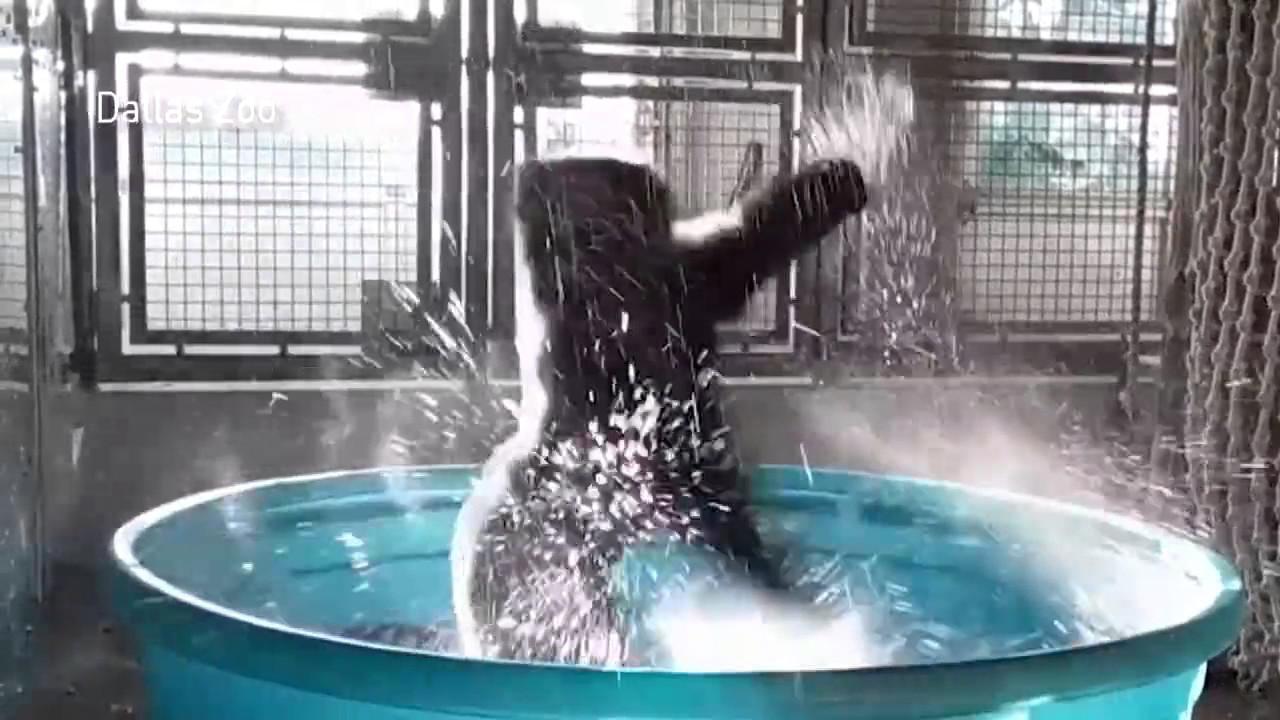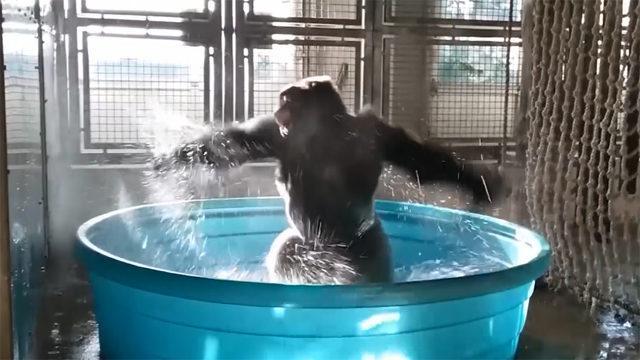The first image is the image on the left, the second image is the image on the right. Assess this claim about the two images: "An image shows one forward-turned gorilla standing in a small blue pool splashing water and posed with both arms outstretched horizontally.". Correct or not? Answer yes or no. Yes. 